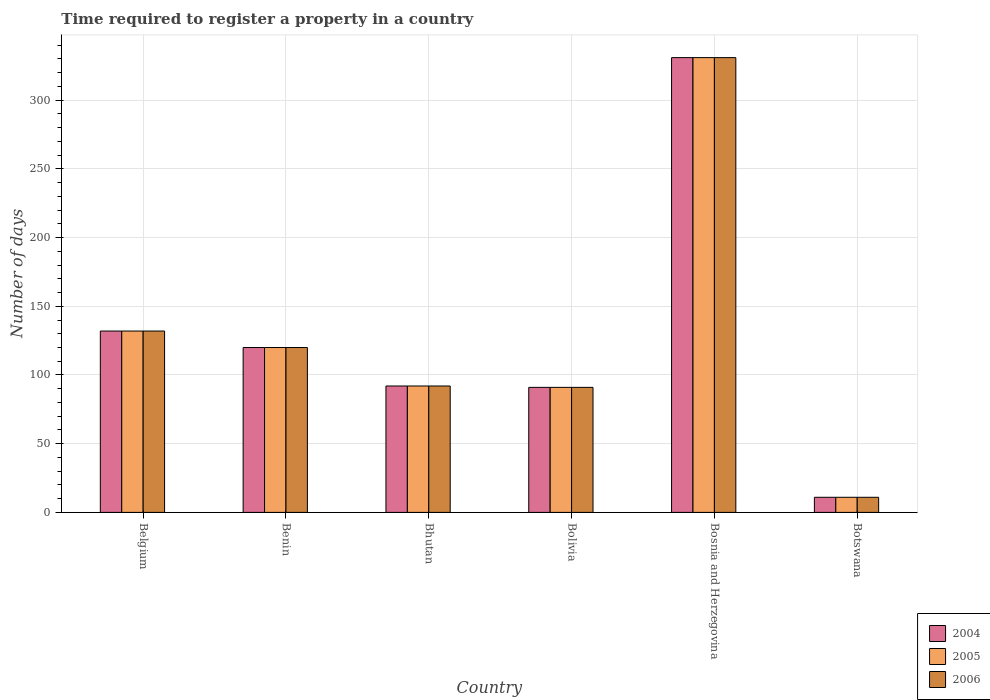How many different coloured bars are there?
Your answer should be very brief. 3. How many bars are there on the 4th tick from the right?
Offer a very short reply. 3. What is the number of days required to register a property in 2004 in Bhutan?
Give a very brief answer. 92. Across all countries, what is the maximum number of days required to register a property in 2005?
Make the answer very short. 331. In which country was the number of days required to register a property in 2005 maximum?
Offer a very short reply. Bosnia and Herzegovina. In which country was the number of days required to register a property in 2004 minimum?
Provide a succinct answer. Botswana. What is the total number of days required to register a property in 2006 in the graph?
Provide a succinct answer. 777. What is the difference between the number of days required to register a property in 2006 in Belgium and the number of days required to register a property in 2005 in Benin?
Your answer should be compact. 12. What is the average number of days required to register a property in 2005 per country?
Make the answer very short. 129.5. What is the difference between the number of days required to register a property of/in 2005 and number of days required to register a property of/in 2004 in Bhutan?
Make the answer very short. 0. In how many countries, is the number of days required to register a property in 2006 greater than 20 days?
Your answer should be very brief. 5. What is the ratio of the number of days required to register a property in 2006 in Benin to that in Bosnia and Herzegovina?
Make the answer very short. 0.36. Is the number of days required to register a property in 2005 in Bhutan less than that in Bolivia?
Provide a succinct answer. No. What is the difference between the highest and the second highest number of days required to register a property in 2004?
Your answer should be compact. -211. What is the difference between the highest and the lowest number of days required to register a property in 2006?
Offer a terse response. 320. In how many countries, is the number of days required to register a property in 2005 greater than the average number of days required to register a property in 2005 taken over all countries?
Your answer should be very brief. 2. Is the sum of the number of days required to register a property in 2005 in Belgium and Botswana greater than the maximum number of days required to register a property in 2004 across all countries?
Offer a terse response. No. What does the 2nd bar from the left in Belgium represents?
Provide a short and direct response. 2005. What does the 2nd bar from the right in Benin represents?
Your answer should be compact. 2005. Is it the case that in every country, the sum of the number of days required to register a property in 2005 and number of days required to register a property in 2004 is greater than the number of days required to register a property in 2006?
Offer a terse response. Yes. How many bars are there?
Offer a very short reply. 18. How many countries are there in the graph?
Make the answer very short. 6. What is the difference between two consecutive major ticks on the Y-axis?
Your answer should be compact. 50. Does the graph contain any zero values?
Offer a terse response. No. Does the graph contain grids?
Your answer should be very brief. Yes. Where does the legend appear in the graph?
Make the answer very short. Bottom right. How are the legend labels stacked?
Make the answer very short. Vertical. What is the title of the graph?
Ensure brevity in your answer.  Time required to register a property in a country. What is the label or title of the X-axis?
Your answer should be compact. Country. What is the label or title of the Y-axis?
Make the answer very short. Number of days. What is the Number of days of 2004 in Belgium?
Your response must be concise. 132. What is the Number of days in 2005 in Belgium?
Make the answer very short. 132. What is the Number of days of 2006 in Belgium?
Make the answer very short. 132. What is the Number of days of 2004 in Benin?
Provide a succinct answer. 120. What is the Number of days of 2005 in Benin?
Your answer should be very brief. 120. What is the Number of days in 2006 in Benin?
Offer a terse response. 120. What is the Number of days in 2004 in Bhutan?
Keep it short and to the point. 92. What is the Number of days in 2005 in Bhutan?
Provide a succinct answer. 92. What is the Number of days of 2006 in Bhutan?
Give a very brief answer. 92. What is the Number of days in 2004 in Bolivia?
Your answer should be very brief. 91. What is the Number of days in 2005 in Bolivia?
Your answer should be compact. 91. What is the Number of days of 2006 in Bolivia?
Offer a very short reply. 91. What is the Number of days in 2004 in Bosnia and Herzegovina?
Offer a terse response. 331. What is the Number of days of 2005 in Bosnia and Herzegovina?
Make the answer very short. 331. What is the Number of days in 2006 in Bosnia and Herzegovina?
Your response must be concise. 331. What is the Number of days of 2004 in Botswana?
Your answer should be very brief. 11. What is the Number of days of 2006 in Botswana?
Your answer should be very brief. 11. Across all countries, what is the maximum Number of days in 2004?
Your answer should be very brief. 331. Across all countries, what is the maximum Number of days in 2005?
Your answer should be compact. 331. Across all countries, what is the maximum Number of days in 2006?
Your answer should be compact. 331. Across all countries, what is the minimum Number of days in 2004?
Your answer should be compact. 11. Across all countries, what is the minimum Number of days in 2005?
Give a very brief answer. 11. Across all countries, what is the minimum Number of days of 2006?
Your answer should be very brief. 11. What is the total Number of days of 2004 in the graph?
Offer a very short reply. 777. What is the total Number of days in 2005 in the graph?
Provide a short and direct response. 777. What is the total Number of days of 2006 in the graph?
Keep it short and to the point. 777. What is the difference between the Number of days in 2006 in Belgium and that in Benin?
Your answer should be very brief. 12. What is the difference between the Number of days of 2004 in Belgium and that in Bhutan?
Your answer should be compact. 40. What is the difference between the Number of days in 2004 in Belgium and that in Bolivia?
Provide a short and direct response. 41. What is the difference between the Number of days in 2004 in Belgium and that in Bosnia and Herzegovina?
Offer a terse response. -199. What is the difference between the Number of days in 2005 in Belgium and that in Bosnia and Herzegovina?
Your answer should be compact. -199. What is the difference between the Number of days of 2006 in Belgium and that in Bosnia and Herzegovina?
Ensure brevity in your answer.  -199. What is the difference between the Number of days in 2004 in Belgium and that in Botswana?
Offer a terse response. 121. What is the difference between the Number of days in 2005 in Belgium and that in Botswana?
Your answer should be very brief. 121. What is the difference between the Number of days of 2006 in Belgium and that in Botswana?
Your answer should be compact. 121. What is the difference between the Number of days of 2004 in Benin and that in Bhutan?
Your response must be concise. 28. What is the difference between the Number of days of 2005 in Benin and that in Bhutan?
Your response must be concise. 28. What is the difference between the Number of days in 2006 in Benin and that in Bhutan?
Offer a very short reply. 28. What is the difference between the Number of days of 2004 in Benin and that in Bolivia?
Your answer should be compact. 29. What is the difference between the Number of days of 2005 in Benin and that in Bolivia?
Give a very brief answer. 29. What is the difference between the Number of days in 2004 in Benin and that in Bosnia and Herzegovina?
Offer a very short reply. -211. What is the difference between the Number of days in 2005 in Benin and that in Bosnia and Herzegovina?
Your answer should be very brief. -211. What is the difference between the Number of days in 2006 in Benin and that in Bosnia and Herzegovina?
Your response must be concise. -211. What is the difference between the Number of days of 2004 in Benin and that in Botswana?
Provide a short and direct response. 109. What is the difference between the Number of days of 2005 in Benin and that in Botswana?
Ensure brevity in your answer.  109. What is the difference between the Number of days of 2006 in Benin and that in Botswana?
Your answer should be very brief. 109. What is the difference between the Number of days of 2004 in Bhutan and that in Bolivia?
Your response must be concise. 1. What is the difference between the Number of days of 2005 in Bhutan and that in Bolivia?
Give a very brief answer. 1. What is the difference between the Number of days of 2006 in Bhutan and that in Bolivia?
Give a very brief answer. 1. What is the difference between the Number of days in 2004 in Bhutan and that in Bosnia and Herzegovina?
Give a very brief answer. -239. What is the difference between the Number of days of 2005 in Bhutan and that in Bosnia and Herzegovina?
Ensure brevity in your answer.  -239. What is the difference between the Number of days of 2006 in Bhutan and that in Bosnia and Herzegovina?
Keep it short and to the point. -239. What is the difference between the Number of days in 2004 in Bhutan and that in Botswana?
Provide a succinct answer. 81. What is the difference between the Number of days of 2006 in Bhutan and that in Botswana?
Give a very brief answer. 81. What is the difference between the Number of days of 2004 in Bolivia and that in Bosnia and Herzegovina?
Provide a succinct answer. -240. What is the difference between the Number of days in 2005 in Bolivia and that in Bosnia and Herzegovina?
Your answer should be compact. -240. What is the difference between the Number of days in 2006 in Bolivia and that in Bosnia and Herzegovina?
Keep it short and to the point. -240. What is the difference between the Number of days in 2004 in Bolivia and that in Botswana?
Provide a succinct answer. 80. What is the difference between the Number of days in 2006 in Bolivia and that in Botswana?
Give a very brief answer. 80. What is the difference between the Number of days in 2004 in Bosnia and Herzegovina and that in Botswana?
Offer a terse response. 320. What is the difference between the Number of days of 2005 in Bosnia and Herzegovina and that in Botswana?
Your answer should be compact. 320. What is the difference between the Number of days of 2006 in Bosnia and Herzegovina and that in Botswana?
Make the answer very short. 320. What is the difference between the Number of days in 2004 in Belgium and the Number of days in 2006 in Benin?
Ensure brevity in your answer.  12. What is the difference between the Number of days in 2005 in Belgium and the Number of days in 2006 in Benin?
Your answer should be very brief. 12. What is the difference between the Number of days in 2004 in Belgium and the Number of days in 2005 in Bhutan?
Provide a short and direct response. 40. What is the difference between the Number of days of 2005 in Belgium and the Number of days of 2006 in Bhutan?
Ensure brevity in your answer.  40. What is the difference between the Number of days of 2004 in Belgium and the Number of days of 2006 in Bolivia?
Your answer should be very brief. 41. What is the difference between the Number of days in 2005 in Belgium and the Number of days in 2006 in Bolivia?
Offer a terse response. 41. What is the difference between the Number of days of 2004 in Belgium and the Number of days of 2005 in Bosnia and Herzegovina?
Keep it short and to the point. -199. What is the difference between the Number of days in 2004 in Belgium and the Number of days in 2006 in Bosnia and Herzegovina?
Provide a short and direct response. -199. What is the difference between the Number of days of 2005 in Belgium and the Number of days of 2006 in Bosnia and Herzegovina?
Your response must be concise. -199. What is the difference between the Number of days in 2004 in Belgium and the Number of days in 2005 in Botswana?
Ensure brevity in your answer.  121. What is the difference between the Number of days of 2004 in Belgium and the Number of days of 2006 in Botswana?
Offer a very short reply. 121. What is the difference between the Number of days in 2005 in Belgium and the Number of days in 2006 in Botswana?
Give a very brief answer. 121. What is the difference between the Number of days of 2004 in Benin and the Number of days of 2005 in Bhutan?
Offer a terse response. 28. What is the difference between the Number of days of 2004 in Benin and the Number of days of 2005 in Bolivia?
Keep it short and to the point. 29. What is the difference between the Number of days in 2004 in Benin and the Number of days in 2005 in Bosnia and Herzegovina?
Keep it short and to the point. -211. What is the difference between the Number of days in 2004 in Benin and the Number of days in 2006 in Bosnia and Herzegovina?
Your response must be concise. -211. What is the difference between the Number of days of 2005 in Benin and the Number of days of 2006 in Bosnia and Herzegovina?
Offer a very short reply. -211. What is the difference between the Number of days of 2004 in Benin and the Number of days of 2005 in Botswana?
Offer a terse response. 109. What is the difference between the Number of days of 2004 in Benin and the Number of days of 2006 in Botswana?
Your answer should be compact. 109. What is the difference between the Number of days of 2005 in Benin and the Number of days of 2006 in Botswana?
Offer a terse response. 109. What is the difference between the Number of days of 2004 in Bhutan and the Number of days of 2006 in Bolivia?
Provide a succinct answer. 1. What is the difference between the Number of days in 2004 in Bhutan and the Number of days in 2005 in Bosnia and Herzegovina?
Your answer should be very brief. -239. What is the difference between the Number of days of 2004 in Bhutan and the Number of days of 2006 in Bosnia and Herzegovina?
Offer a terse response. -239. What is the difference between the Number of days of 2005 in Bhutan and the Number of days of 2006 in Bosnia and Herzegovina?
Provide a short and direct response. -239. What is the difference between the Number of days of 2004 in Bhutan and the Number of days of 2006 in Botswana?
Provide a short and direct response. 81. What is the difference between the Number of days in 2004 in Bolivia and the Number of days in 2005 in Bosnia and Herzegovina?
Ensure brevity in your answer.  -240. What is the difference between the Number of days of 2004 in Bolivia and the Number of days of 2006 in Bosnia and Herzegovina?
Give a very brief answer. -240. What is the difference between the Number of days in 2005 in Bolivia and the Number of days in 2006 in Bosnia and Herzegovina?
Make the answer very short. -240. What is the difference between the Number of days of 2004 in Bolivia and the Number of days of 2005 in Botswana?
Make the answer very short. 80. What is the difference between the Number of days of 2004 in Bolivia and the Number of days of 2006 in Botswana?
Keep it short and to the point. 80. What is the difference between the Number of days of 2004 in Bosnia and Herzegovina and the Number of days of 2005 in Botswana?
Your answer should be compact. 320. What is the difference between the Number of days in 2004 in Bosnia and Herzegovina and the Number of days in 2006 in Botswana?
Ensure brevity in your answer.  320. What is the difference between the Number of days of 2005 in Bosnia and Herzegovina and the Number of days of 2006 in Botswana?
Offer a terse response. 320. What is the average Number of days of 2004 per country?
Offer a very short reply. 129.5. What is the average Number of days in 2005 per country?
Provide a short and direct response. 129.5. What is the average Number of days in 2006 per country?
Provide a succinct answer. 129.5. What is the difference between the Number of days of 2004 and Number of days of 2006 in Belgium?
Ensure brevity in your answer.  0. What is the difference between the Number of days in 2004 and Number of days in 2006 in Bhutan?
Your answer should be very brief. 0. What is the difference between the Number of days of 2005 and Number of days of 2006 in Bhutan?
Give a very brief answer. 0. What is the difference between the Number of days in 2004 and Number of days in 2005 in Bolivia?
Your answer should be very brief. 0. What is the difference between the Number of days of 2005 and Number of days of 2006 in Bolivia?
Give a very brief answer. 0. What is the difference between the Number of days of 2004 and Number of days of 2005 in Bosnia and Herzegovina?
Provide a short and direct response. 0. What is the difference between the Number of days in 2004 and Number of days in 2006 in Bosnia and Herzegovina?
Provide a succinct answer. 0. What is the difference between the Number of days in 2004 and Number of days in 2005 in Botswana?
Offer a very short reply. 0. What is the difference between the Number of days in 2004 and Number of days in 2006 in Botswana?
Your answer should be compact. 0. What is the difference between the Number of days in 2005 and Number of days in 2006 in Botswana?
Offer a very short reply. 0. What is the ratio of the Number of days of 2004 in Belgium to that in Benin?
Provide a succinct answer. 1.1. What is the ratio of the Number of days of 2005 in Belgium to that in Benin?
Ensure brevity in your answer.  1.1. What is the ratio of the Number of days in 2004 in Belgium to that in Bhutan?
Make the answer very short. 1.43. What is the ratio of the Number of days of 2005 in Belgium to that in Bhutan?
Provide a succinct answer. 1.43. What is the ratio of the Number of days in 2006 in Belgium to that in Bhutan?
Make the answer very short. 1.43. What is the ratio of the Number of days in 2004 in Belgium to that in Bolivia?
Your response must be concise. 1.45. What is the ratio of the Number of days of 2005 in Belgium to that in Bolivia?
Keep it short and to the point. 1.45. What is the ratio of the Number of days of 2006 in Belgium to that in Bolivia?
Provide a short and direct response. 1.45. What is the ratio of the Number of days of 2004 in Belgium to that in Bosnia and Herzegovina?
Keep it short and to the point. 0.4. What is the ratio of the Number of days in 2005 in Belgium to that in Bosnia and Herzegovina?
Provide a succinct answer. 0.4. What is the ratio of the Number of days of 2006 in Belgium to that in Bosnia and Herzegovina?
Keep it short and to the point. 0.4. What is the ratio of the Number of days of 2004 in Belgium to that in Botswana?
Offer a very short reply. 12. What is the ratio of the Number of days of 2005 in Belgium to that in Botswana?
Provide a short and direct response. 12. What is the ratio of the Number of days of 2004 in Benin to that in Bhutan?
Your response must be concise. 1.3. What is the ratio of the Number of days in 2005 in Benin to that in Bhutan?
Make the answer very short. 1.3. What is the ratio of the Number of days in 2006 in Benin to that in Bhutan?
Offer a very short reply. 1.3. What is the ratio of the Number of days of 2004 in Benin to that in Bolivia?
Your response must be concise. 1.32. What is the ratio of the Number of days of 2005 in Benin to that in Bolivia?
Offer a very short reply. 1.32. What is the ratio of the Number of days of 2006 in Benin to that in Bolivia?
Provide a succinct answer. 1.32. What is the ratio of the Number of days in 2004 in Benin to that in Bosnia and Herzegovina?
Your response must be concise. 0.36. What is the ratio of the Number of days of 2005 in Benin to that in Bosnia and Herzegovina?
Keep it short and to the point. 0.36. What is the ratio of the Number of days in 2006 in Benin to that in Bosnia and Herzegovina?
Provide a succinct answer. 0.36. What is the ratio of the Number of days of 2004 in Benin to that in Botswana?
Provide a short and direct response. 10.91. What is the ratio of the Number of days of 2005 in Benin to that in Botswana?
Offer a terse response. 10.91. What is the ratio of the Number of days in 2006 in Benin to that in Botswana?
Ensure brevity in your answer.  10.91. What is the ratio of the Number of days in 2005 in Bhutan to that in Bolivia?
Keep it short and to the point. 1.01. What is the ratio of the Number of days of 2004 in Bhutan to that in Bosnia and Herzegovina?
Your response must be concise. 0.28. What is the ratio of the Number of days of 2005 in Bhutan to that in Bosnia and Herzegovina?
Offer a very short reply. 0.28. What is the ratio of the Number of days of 2006 in Bhutan to that in Bosnia and Herzegovina?
Your answer should be very brief. 0.28. What is the ratio of the Number of days in 2004 in Bhutan to that in Botswana?
Your answer should be compact. 8.36. What is the ratio of the Number of days in 2005 in Bhutan to that in Botswana?
Provide a succinct answer. 8.36. What is the ratio of the Number of days in 2006 in Bhutan to that in Botswana?
Give a very brief answer. 8.36. What is the ratio of the Number of days of 2004 in Bolivia to that in Bosnia and Herzegovina?
Your response must be concise. 0.27. What is the ratio of the Number of days in 2005 in Bolivia to that in Bosnia and Herzegovina?
Offer a terse response. 0.27. What is the ratio of the Number of days of 2006 in Bolivia to that in Bosnia and Herzegovina?
Ensure brevity in your answer.  0.27. What is the ratio of the Number of days in 2004 in Bolivia to that in Botswana?
Make the answer very short. 8.27. What is the ratio of the Number of days in 2005 in Bolivia to that in Botswana?
Keep it short and to the point. 8.27. What is the ratio of the Number of days in 2006 in Bolivia to that in Botswana?
Offer a very short reply. 8.27. What is the ratio of the Number of days of 2004 in Bosnia and Herzegovina to that in Botswana?
Your answer should be very brief. 30.09. What is the ratio of the Number of days of 2005 in Bosnia and Herzegovina to that in Botswana?
Ensure brevity in your answer.  30.09. What is the ratio of the Number of days in 2006 in Bosnia and Herzegovina to that in Botswana?
Your answer should be very brief. 30.09. What is the difference between the highest and the second highest Number of days of 2004?
Offer a very short reply. 199. What is the difference between the highest and the second highest Number of days of 2005?
Your answer should be compact. 199. What is the difference between the highest and the second highest Number of days of 2006?
Provide a succinct answer. 199. What is the difference between the highest and the lowest Number of days of 2004?
Ensure brevity in your answer.  320. What is the difference between the highest and the lowest Number of days of 2005?
Give a very brief answer. 320. What is the difference between the highest and the lowest Number of days of 2006?
Keep it short and to the point. 320. 